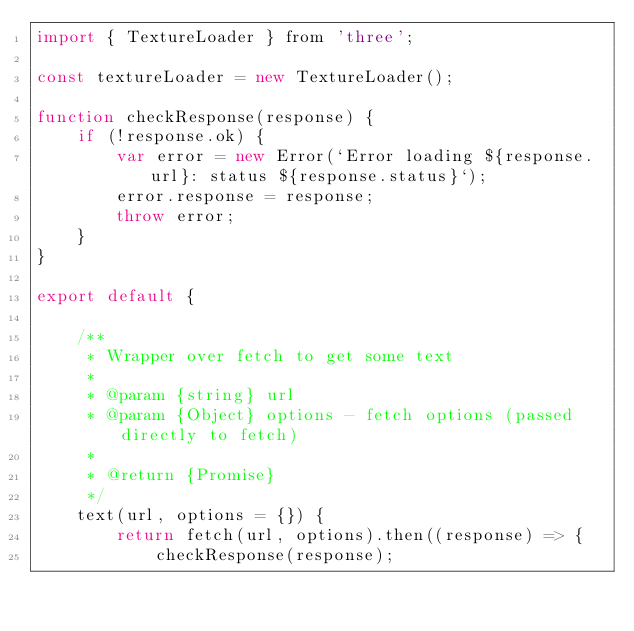<code> <loc_0><loc_0><loc_500><loc_500><_JavaScript_>import { TextureLoader } from 'three';

const textureLoader = new TextureLoader();

function checkResponse(response) {
    if (!response.ok) {
        var error = new Error(`Error loading ${response.url}: status ${response.status}`);
        error.response = response;
        throw error;
    }
}

export default {

    /**
     * Wrapper over fetch to get some text
     *
     * @param {string} url
     * @param {Object} options - fetch options (passed directly to fetch)
     *
     * @return {Promise}
     */
    text(url, options = {}) {
        return fetch(url, options).then((response) => {
            checkResponse(response);</code> 